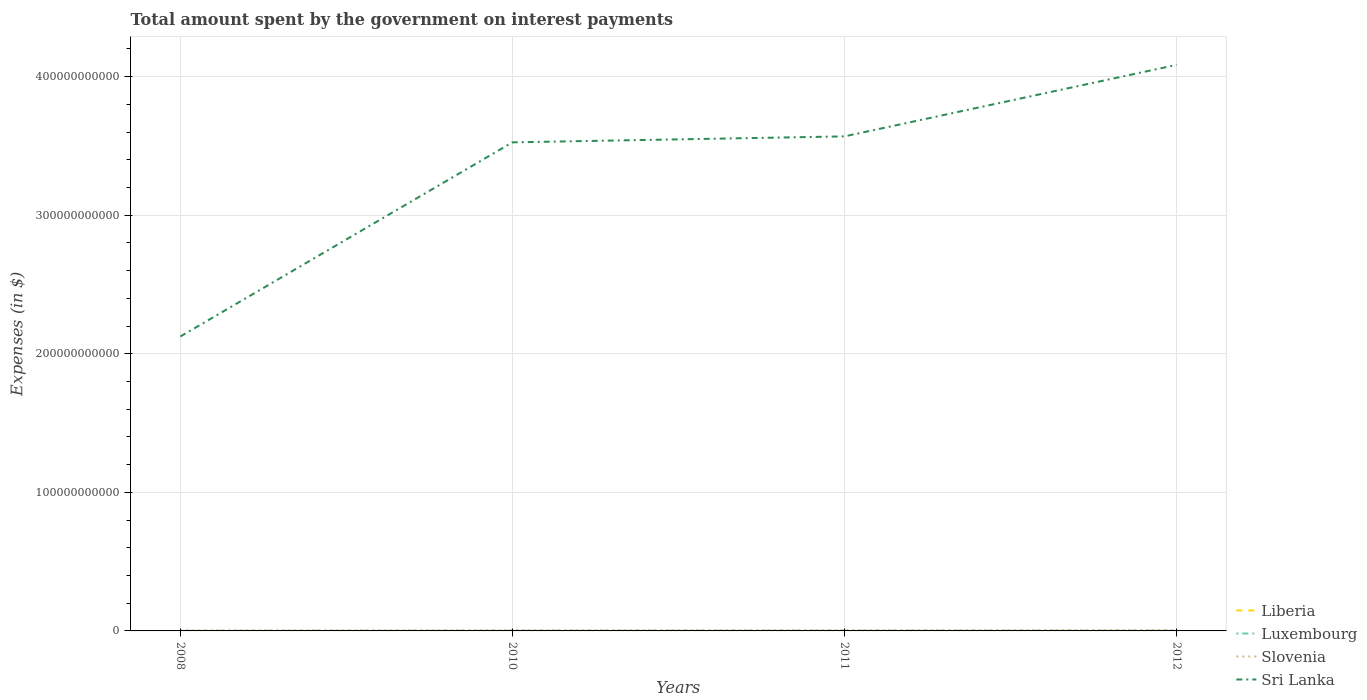How many different coloured lines are there?
Provide a short and direct response. 4. Does the line corresponding to Sri Lanka intersect with the line corresponding to Luxembourg?
Offer a very short reply. No. Across all years, what is the maximum amount spent on interest payments by the government in Luxembourg?
Make the answer very short. 8.89e+07. In which year was the amount spent on interest payments by the government in Sri Lanka maximum?
Offer a very short reply. 2008. What is the total amount spent on interest payments by the government in Slovenia in the graph?
Offer a very short reply. -1.58e+08. What is the difference between the highest and the second highest amount spent on interest payments by the government in Liberia?
Your answer should be very brief. 1.98e+05. Is the amount spent on interest payments by the government in Sri Lanka strictly greater than the amount spent on interest payments by the government in Luxembourg over the years?
Your response must be concise. No. How many lines are there?
Your answer should be compact. 4. How many years are there in the graph?
Your answer should be compact. 4. What is the difference between two consecutive major ticks on the Y-axis?
Provide a succinct answer. 1.00e+11. Are the values on the major ticks of Y-axis written in scientific E-notation?
Keep it short and to the point. No. Where does the legend appear in the graph?
Make the answer very short. Bottom right. How are the legend labels stacked?
Offer a terse response. Vertical. What is the title of the graph?
Keep it short and to the point. Total amount spent by the government on interest payments. What is the label or title of the Y-axis?
Your response must be concise. Expenses (in $). What is the Expenses (in $) in Liberia in 2008?
Offer a very short reply. 7.01e+04. What is the Expenses (in $) of Luxembourg in 2008?
Give a very brief answer. 8.89e+07. What is the Expenses (in $) in Slovenia in 2008?
Keep it short and to the point. 4.04e+08. What is the Expenses (in $) in Sri Lanka in 2008?
Provide a short and direct response. 2.12e+11. What is the Expenses (in $) in Liberia in 2010?
Your response must be concise. 1.88e+05. What is the Expenses (in $) in Luxembourg in 2010?
Offer a very short reply. 1.51e+08. What is the Expenses (in $) in Slovenia in 2010?
Provide a succinct answer. 5.44e+08. What is the Expenses (in $) in Sri Lanka in 2010?
Keep it short and to the point. 3.53e+11. What is the Expenses (in $) in Liberia in 2011?
Your answer should be very brief. 2.44e+05. What is the Expenses (in $) of Luxembourg in 2011?
Provide a short and direct response. 1.86e+08. What is the Expenses (in $) in Slovenia in 2011?
Your answer should be compact. 5.61e+08. What is the Expenses (in $) of Sri Lanka in 2011?
Provide a short and direct response. 3.57e+11. What is the Expenses (in $) of Liberia in 2012?
Offer a terse response. 4.63e+04. What is the Expenses (in $) in Luxembourg in 2012?
Offer a very short reply. 1.96e+08. What is the Expenses (in $) of Slovenia in 2012?
Ensure brevity in your answer.  7.02e+08. What is the Expenses (in $) of Sri Lanka in 2012?
Offer a terse response. 4.08e+11. Across all years, what is the maximum Expenses (in $) in Liberia?
Provide a succinct answer. 2.44e+05. Across all years, what is the maximum Expenses (in $) in Luxembourg?
Provide a short and direct response. 1.96e+08. Across all years, what is the maximum Expenses (in $) in Slovenia?
Offer a terse response. 7.02e+08. Across all years, what is the maximum Expenses (in $) of Sri Lanka?
Keep it short and to the point. 4.08e+11. Across all years, what is the minimum Expenses (in $) of Liberia?
Offer a terse response. 4.63e+04. Across all years, what is the minimum Expenses (in $) in Luxembourg?
Offer a terse response. 8.89e+07. Across all years, what is the minimum Expenses (in $) in Slovenia?
Offer a very short reply. 4.04e+08. Across all years, what is the minimum Expenses (in $) in Sri Lanka?
Your response must be concise. 2.12e+11. What is the total Expenses (in $) in Liberia in the graph?
Your response must be concise. 5.49e+05. What is the total Expenses (in $) in Luxembourg in the graph?
Ensure brevity in your answer.  6.22e+08. What is the total Expenses (in $) of Slovenia in the graph?
Ensure brevity in your answer.  2.21e+09. What is the total Expenses (in $) in Sri Lanka in the graph?
Your answer should be very brief. 1.33e+12. What is the difference between the Expenses (in $) in Liberia in 2008 and that in 2010?
Provide a succinct answer. -1.18e+05. What is the difference between the Expenses (in $) of Luxembourg in 2008 and that in 2010?
Offer a very short reply. -6.20e+07. What is the difference between the Expenses (in $) in Slovenia in 2008 and that in 2010?
Keep it short and to the point. -1.40e+08. What is the difference between the Expenses (in $) of Sri Lanka in 2008 and that in 2010?
Your response must be concise. -1.40e+11. What is the difference between the Expenses (in $) of Liberia in 2008 and that in 2011?
Ensure brevity in your answer.  -1.74e+05. What is the difference between the Expenses (in $) of Luxembourg in 2008 and that in 2011?
Ensure brevity in your answer.  -9.67e+07. What is the difference between the Expenses (in $) in Slovenia in 2008 and that in 2011?
Make the answer very short. -1.57e+08. What is the difference between the Expenses (in $) in Sri Lanka in 2008 and that in 2011?
Provide a short and direct response. -1.44e+11. What is the difference between the Expenses (in $) of Liberia in 2008 and that in 2012?
Ensure brevity in your answer.  2.38e+04. What is the difference between the Expenses (in $) of Luxembourg in 2008 and that in 2012?
Offer a terse response. -1.07e+08. What is the difference between the Expenses (in $) of Slovenia in 2008 and that in 2012?
Ensure brevity in your answer.  -2.99e+08. What is the difference between the Expenses (in $) of Sri Lanka in 2008 and that in 2012?
Your answer should be very brief. -1.96e+11. What is the difference between the Expenses (in $) of Liberia in 2010 and that in 2011?
Make the answer very short. -5.61e+04. What is the difference between the Expenses (in $) of Luxembourg in 2010 and that in 2011?
Your answer should be compact. -3.47e+07. What is the difference between the Expenses (in $) in Slovenia in 2010 and that in 2011?
Ensure brevity in your answer.  -1.68e+07. What is the difference between the Expenses (in $) of Sri Lanka in 2010 and that in 2011?
Provide a short and direct response. -4.31e+09. What is the difference between the Expenses (in $) of Liberia in 2010 and that in 2012?
Offer a very short reply. 1.42e+05. What is the difference between the Expenses (in $) of Luxembourg in 2010 and that in 2012?
Offer a very short reply. -4.55e+07. What is the difference between the Expenses (in $) in Slovenia in 2010 and that in 2012?
Give a very brief answer. -1.58e+08. What is the difference between the Expenses (in $) of Sri Lanka in 2010 and that in 2012?
Give a very brief answer. -5.59e+1. What is the difference between the Expenses (in $) in Liberia in 2011 and that in 2012?
Your answer should be compact. 1.98e+05. What is the difference between the Expenses (in $) in Luxembourg in 2011 and that in 2012?
Offer a terse response. -1.07e+07. What is the difference between the Expenses (in $) in Slovenia in 2011 and that in 2012?
Your answer should be compact. -1.41e+08. What is the difference between the Expenses (in $) of Sri Lanka in 2011 and that in 2012?
Your response must be concise. -5.16e+1. What is the difference between the Expenses (in $) in Liberia in 2008 and the Expenses (in $) in Luxembourg in 2010?
Your answer should be very brief. -1.51e+08. What is the difference between the Expenses (in $) in Liberia in 2008 and the Expenses (in $) in Slovenia in 2010?
Your answer should be compact. -5.44e+08. What is the difference between the Expenses (in $) of Liberia in 2008 and the Expenses (in $) of Sri Lanka in 2010?
Give a very brief answer. -3.53e+11. What is the difference between the Expenses (in $) of Luxembourg in 2008 and the Expenses (in $) of Slovenia in 2010?
Offer a very short reply. -4.55e+08. What is the difference between the Expenses (in $) in Luxembourg in 2008 and the Expenses (in $) in Sri Lanka in 2010?
Ensure brevity in your answer.  -3.53e+11. What is the difference between the Expenses (in $) of Slovenia in 2008 and the Expenses (in $) of Sri Lanka in 2010?
Keep it short and to the point. -3.52e+11. What is the difference between the Expenses (in $) of Liberia in 2008 and the Expenses (in $) of Luxembourg in 2011?
Your answer should be compact. -1.86e+08. What is the difference between the Expenses (in $) of Liberia in 2008 and the Expenses (in $) of Slovenia in 2011?
Provide a succinct answer. -5.61e+08. What is the difference between the Expenses (in $) in Liberia in 2008 and the Expenses (in $) in Sri Lanka in 2011?
Offer a terse response. -3.57e+11. What is the difference between the Expenses (in $) in Luxembourg in 2008 and the Expenses (in $) in Slovenia in 2011?
Your answer should be very brief. -4.72e+08. What is the difference between the Expenses (in $) of Luxembourg in 2008 and the Expenses (in $) of Sri Lanka in 2011?
Offer a terse response. -3.57e+11. What is the difference between the Expenses (in $) of Slovenia in 2008 and the Expenses (in $) of Sri Lanka in 2011?
Provide a succinct answer. -3.56e+11. What is the difference between the Expenses (in $) of Liberia in 2008 and the Expenses (in $) of Luxembourg in 2012?
Your answer should be very brief. -1.96e+08. What is the difference between the Expenses (in $) of Liberia in 2008 and the Expenses (in $) of Slovenia in 2012?
Provide a succinct answer. -7.02e+08. What is the difference between the Expenses (in $) of Liberia in 2008 and the Expenses (in $) of Sri Lanka in 2012?
Give a very brief answer. -4.08e+11. What is the difference between the Expenses (in $) of Luxembourg in 2008 and the Expenses (in $) of Slovenia in 2012?
Your response must be concise. -6.14e+08. What is the difference between the Expenses (in $) of Luxembourg in 2008 and the Expenses (in $) of Sri Lanka in 2012?
Your answer should be compact. -4.08e+11. What is the difference between the Expenses (in $) in Slovenia in 2008 and the Expenses (in $) in Sri Lanka in 2012?
Make the answer very short. -4.08e+11. What is the difference between the Expenses (in $) of Liberia in 2010 and the Expenses (in $) of Luxembourg in 2011?
Offer a very short reply. -1.85e+08. What is the difference between the Expenses (in $) of Liberia in 2010 and the Expenses (in $) of Slovenia in 2011?
Provide a short and direct response. -5.61e+08. What is the difference between the Expenses (in $) of Liberia in 2010 and the Expenses (in $) of Sri Lanka in 2011?
Provide a succinct answer. -3.57e+11. What is the difference between the Expenses (in $) of Luxembourg in 2010 and the Expenses (in $) of Slovenia in 2011?
Keep it short and to the point. -4.10e+08. What is the difference between the Expenses (in $) of Luxembourg in 2010 and the Expenses (in $) of Sri Lanka in 2011?
Provide a short and direct response. -3.57e+11. What is the difference between the Expenses (in $) of Slovenia in 2010 and the Expenses (in $) of Sri Lanka in 2011?
Make the answer very short. -3.56e+11. What is the difference between the Expenses (in $) of Liberia in 2010 and the Expenses (in $) of Luxembourg in 2012?
Offer a very short reply. -1.96e+08. What is the difference between the Expenses (in $) in Liberia in 2010 and the Expenses (in $) in Slovenia in 2012?
Give a very brief answer. -7.02e+08. What is the difference between the Expenses (in $) of Liberia in 2010 and the Expenses (in $) of Sri Lanka in 2012?
Keep it short and to the point. -4.08e+11. What is the difference between the Expenses (in $) of Luxembourg in 2010 and the Expenses (in $) of Slovenia in 2012?
Offer a terse response. -5.52e+08. What is the difference between the Expenses (in $) in Luxembourg in 2010 and the Expenses (in $) in Sri Lanka in 2012?
Ensure brevity in your answer.  -4.08e+11. What is the difference between the Expenses (in $) of Slovenia in 2010 and the Expenses (in $) of Sri Lanka in 2012?
Your answer should be compact. -4.08e+11. What is the difference between the Expenses (in $) of Liberia in 2011 and the Expenses (in $) of Luxembourg in 2012?
Keep it short and to the point. -1.96e+08. What is the difference between the Expenses (in $) of Liberia in 2011 and the Expenses (in $) of Slovenia in 2012?
Ensure brevity in your answer.  -7.02e+08. What is the difference between the Expenses (in $) in Liberia in 2011 and the Expenses (in $) in Sri Lanka in 2012?
Your answer should be very brief. -4.08e+11. What is the difference between the Expenses (in $) of Luxembourg in 2011 and the Expenses (in $) of Slovenia in 2012?
Provide a short and direct response. -5.17e+08. What is the difference between the Expenses (in $) of Luxembourg in 2011 and the Expenses (in $) of Sri Lanka in 2012?
Offer a very short reply. -4.08e+11. What is the difference between the Expenses (in $) in Slovenia in 2011 and the Expenses (in $) in Sri Lanka in 2012?
Provide a succinct answer. -4.08e+11. What is the average Expenses (in $) of Liberia per year?
Your answer should be very brief. 1.37e+05. What is the average Expenses (in $) of Luxembourg per year?
Your answer should be very brief. 1.55e+08. What is the average Expenses (in $) in Slovenia per year?
Provide a short and direct response. 5.53e+08. What is the average Expenses (in $) of Sri Lanka per year?
Provide a succinct answer. 3.33e+11. In the year 2008, what is the difference between the Expenses (in $) of Liberia and Expenses (in $) of Luxembourg?
Your response must be concise. -8.88e+07. In the year 2008, what is the difference between the Expenses (in $) in Liberia and Expenses (in $) in Slovenia?
Provide a short and direct response. -4.04e+08. In the year 2008, what is the difference between the Expenses (in $) of Liberia and Expenses (in $) of Sri Lanka?
Your answer should be very brief. -2.12e+11. In the year 2008, what is the difference between the Expenses (in $) in Luxembourg and Expenses (in $) in Slovenia?
Ensure brevity in your answer.  -3.15e+08. In the year 2008, what is the difference between the Expenses (in $) of Luxembourg and Expenses (in $) of Sri Lanka?
Your response must be concise. -2.12e+11. In the year 2008, what is the difference between the Expenses (in $) of Slovenia and Expenses (in $) of Sri Lanka?
Keep it short and to the point. -2.12e+11. In the year 2010, what is the difference between the Expenses (in $) in Liberia and Expenses (in $) in Luxembourg?
Offer a very short reply. -1.51e+08. In the year 2010, what is the difference between the Expenses (in $) in Liberia and Expenses (in $) in Slovenia?
Keep it short and to the point. -5.44e+08. In the year 2010, what is the difference between the Expenses (in $) of Liberia and Expenses (in $) of Sri Lanka?
Give a very brief answer. -3.53e+11. In the year 2010, what is the difference between the Expenses (in $) in Luxembourg and Expenses (in $) in Slovenia?
Offer a very short reply. -3.93e+08. In the year 2010, what is the difference between the Expenses (in $) in Luxembourg and Expenses (in $) in Sri Lanka?
Provide a succinct answer. -3.52e+11. In the year 2010, what is the difference between the Expenses (in $) of Slovenia and Expenses (in $) of Sri Lanka?
Offer a very short reply. -3.52e+11. In the year 2011, what is the difference between the Expenses (in $) in Liberia and Expenses (in $) in Luxembourg?
Keep it short and to the point. -1.85e+08. In the year 2011, what is the difference between the Expenses (in $) of Liberia and Expenses (in $) of Slovenia?
Provide a succinct answer. -5.61e+08. In the year 2011, what is the difference between the Expenses (in $) of Liberia and Expenses (in $) of Sri Lanka?
Make the answer very short. -3.57e+11. In the year 2011, what is the difference between the Expenses (in $) in Luxembourg and Expenses (in $) in Slovenia?
Your answer should be compact. -3.75e+08. In the year 2011, what is the difference between the Expenses (in $) in Luxembourg and Expenses (in $) in Sri Lanka?
Your response must be concise. -3.57e+11. In the year 2011, what is the difference between the Expenses (in $) in Slovenia and Expenses (in $) in Sri Lanka?
Your answer should be very brief. -3.56e+11. In the year 2012, what is the difference between the Expenses (in $) in Liberia and Expenses (in $) in Luxembourg?
Give a very brief answer. -1.96e+08. In the year 2012, what is the difference between the Expenses (in $) in Liberia and Expenses (in $) in Slovenia?
Ensure brevity in your answer.  -7.02e+08. In the year 2012, what is the difference between the Expenses (in $) in Liberia and Expenses (in $) in Sri Lanka?
Your answer should be very brief. -4.08e+11. In the year 2012, what is the difference between the Expenses (in $) of Luxembourg and Expenses (in $) of Slovenia?
Give a very brief answer. -5.06e+08. In the year 2012, what is the difference between the Expenses (in $) of Luxembourg and Expenses (in $) of Sri Lanka?
Provide a succinct answer. -4.08e+11. In the year 2012, what is the difference between the Expenses (in $) of Slovenia and Expenses (in $) of Sri Lanka?
Offer a very short reply. -4.08e+11. What is the ratio of the Expenses (in $) in Liberia in 2008 to that in 2010?
Make the answer very short. 0.37. What is the ratio of the Expenses (in $) of Luxembourg in 2008 to that in 2010?
Keep it short and to the point. 0.59. What is the ratio of the Expenses (in $) of Slovenia in 2008 to that in 2010?
Your answer should be compact. 0.74. What is the ratio of the Expenses (in $) in Sri Lanka in 2008 to that in 2010?
Keep it short and to the point. 0.6. What is the ratio of the Expenses (in $) in Liberia in 2008 to that in 2011?
Make the answer very short. 0.29. What is the ratio of the Expenses (in $) in Luxembourg in 2008 to that in 2011?
Give a very brief answer. 0.48. What is the ratio of the Expenses (in $) in Slovenia in 2008 to that in 2011?
Offer a terse response. 0.72. What is the ratio of the Expenses (in $) of Sri Lanka in 2008 to that in 2011?
Give a very brief answer. 0.6. What is the ratio of the Expenses (in $) in Liberia in 2008 to that in 2012?
Give a very brief answer. 1.51. What is the ratio of the Expenses (in $) in Luxembourg in 2008 to that in 2012?
Keep it short and to the point. 0.45. What is the ratio of the Expenses (in $) of Slovenia in 2008 to that in 2012?
Your response must be concise. 0.57. What is the ratio of the Expenses (in $) of Sri Lanka in 2008 to that in 2012?
Offer a very short reply. 0.52. What is the ratio of the Expenses (in $) in Liberia in 2010 to that in 2011?
Offer a terse response. 0.77. What is the ratio of the Expenses (in $) of Luxembourg in 2010 to that in 2011?
Make the answer very short. 0.81. What is the ratio of the Expenses (in $) in Slovenia in 2010 to that in 2011?
Provide a succinct answer. 0.97. What is the ratio of the Expenses (in $) of Sri Lanka in 2010 to that in 2011?
Offer a very short reply. 0.99. What is the ratio of the Expenses (in $) of Liberia in 2010 to that in 2012?
Provide a short and direct response. 4.06. What is the ratio of the Expenses (in $) of Luxembourg in 2010 to that in 2012?
Offer a terse response. 0.77. What is the ratio of the Expenses (in $) of Slovenia in 2010 to that in 2012?
Provide a succinct answer. 0.77. What is the ratio of the Expenses (in $) of Sri Lanka in 2010 to that in 2012?
Give a very brief answer. 0.86. What is the ratio of the Expenses (in $) in Liberia in 2011 to that in 2012?
Offer a terse response. 5.28. What is the ratio of the Expenses (in $) in Luxembourg in 2011 to that in 2012?
Give a very brief answer. 0.95. What is the ratio of the Expenses (in $) in Slovenia in 2011 to that in 2012?
Your answer should be very brief. 0.8. What is the ratio of the Expenses (in $) of Sri Lanka in 2011 to that in 2012?
Offer a terse response. 0.87. What is the difference between the highest and the second highest Expenses (in $) in Liberia?
Keep it short and to the point. 5.61e+04. What is the difference between the highest and the second highest Expenses (in $) of Luxembourg?
Offer a very short reply. 1.07e+07. What is the difference between the highest and the second highest Expenses (in $) in Slovenia?
Keep it short and to the point. 1.41e+08. What is the difference between the highest and the second highest Expenses (in $) in Sri Lanka?
Your answer should be very brief. 5.16e+1. What is the difference between the highest and the lowest Expenses (in $) in Liberia?
Your answer should be very brief. 1.98e+05. What is the difference between the highest and the lowest Expenses (in $) of Luxembourg?
Make the answer very short. 1.07e+08. What is the difference between the highest and the lowest Expenses (in $) in Slovenia?
Offer a very short reply. 2.99e+08. What is the difference between the highest and the lowest Expenses (in $) of Sri Lanka?
Make the answer very short. 1.96e+11. 